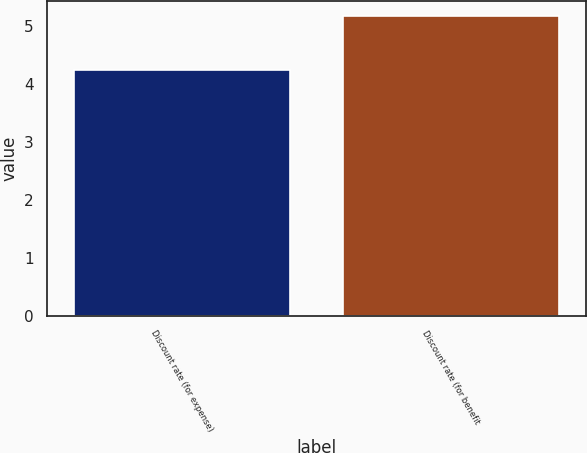<chart> <loc_0><loc_0><loc_500><loc_500><bar_chart><fcel>Discount rate (for expense)<fcel>Discount rate (for benefit<nl><fcel>4.25<fcel>5.17<nl></chart> 